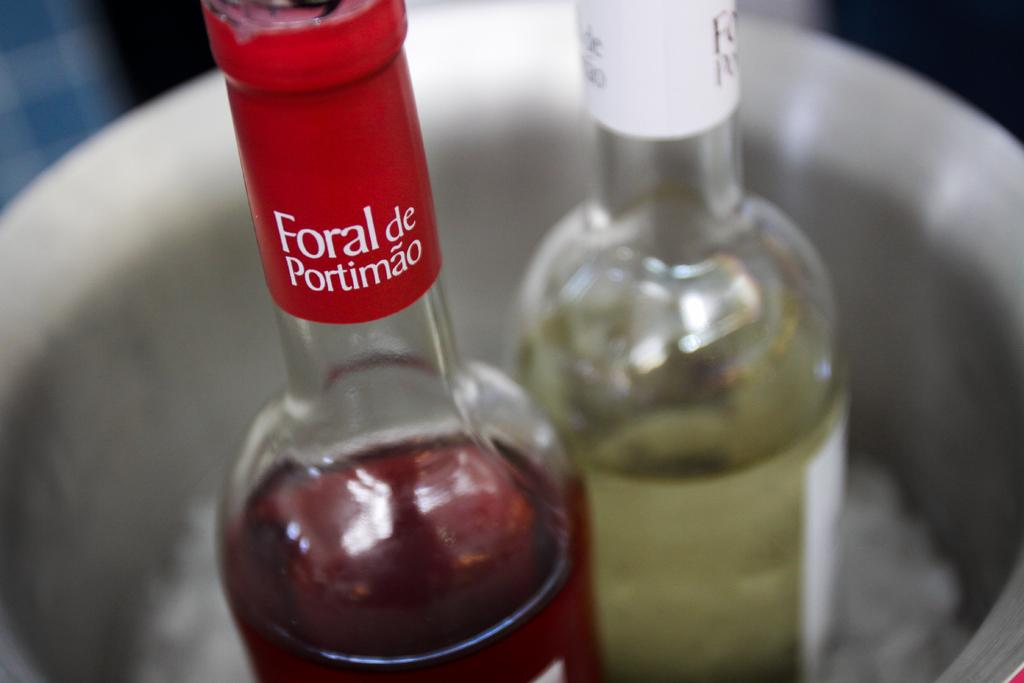<image>
Summarize the visual content of the image. Two bottle of Foral De Portimao win on ice. 